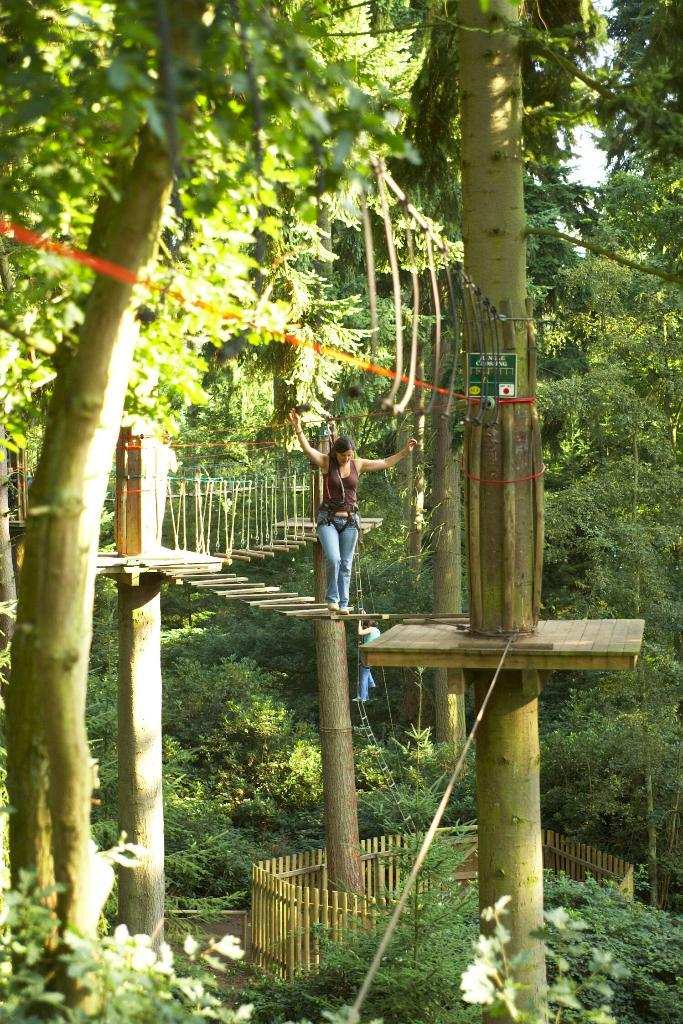Who is present in the image? There is a woman in the image. What is the woman wearing? The woman is wearing clothes and shoes. What is the woman doing in the image? The woman is walking. What can be seen in the background of the image? There is a fence, trees, and plants in the image. What is the color of the sky in the image? The sky is white in the image. How many children is the woman caring for in the image? There are no children present in the image, so it is not possible to determine how many the woman might be caring for. 